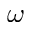<formula> <loc_0><loc_0><loc_500><loc_500>\omega</formula> 